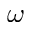<formula> <loc_0><loc_0><loc_500><loc_500>\omega</formula> 